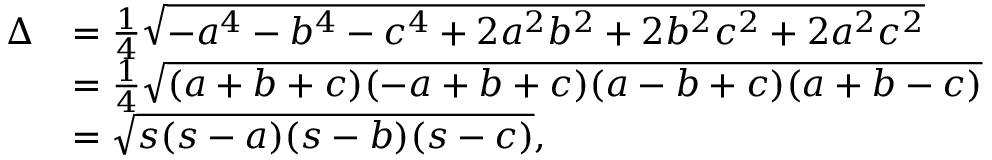<formula> <loc_0><loc_0><loc_500><loc_500>{ \begin{array} { r l } { \Delta } & { = { \frac { 1 } { 4 } } { \sqrt { - a ^ { 4 } - b ^ { 4 } - c ^ { 4 } + 2 a ^ { 2 } b ^ { 2 } + 2 b ^ { 2 } c ^ { 2 } + 2 a ^ { 2 } c ^ { 2 } } } } \\ & { = { \frac { 1 } { 4 } } { \sqrt { ( a + b + c ) ( - a + b + c ) ( a - b + c ) ( a + b - c ) } } } \\ & { = { \sqrt { s ( s - a ) ( s - b ) ( s - c ) } } , } \end{array} }</formula> 